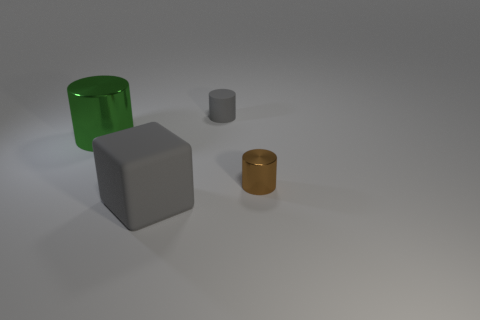Add 3 small metal cylinders. How many objects exist? 7 Subtract all cylinders. How many objects are left? 1 Subtract 0 gray spheres. How many objects are left? 4 Subtract all small red metallic things. Subtract all small cylinders. How many objects are left? 2 Add 4 gray rubber things. How many gray rubber things are left? 6 Add 2 small cyan matte objects. How many small cyan matte objects exist? 2 